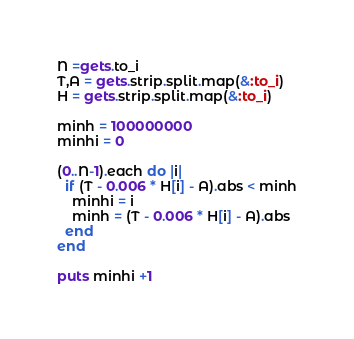Convert code to text. <code><loc_0><loc_0><loc_500><loc_500><_Ruby_>N =gets.to_i
T,A = gets.strip.split.map(&:to_i)
H = gets.strip.split.map(&:to_i)

minh = 100000000
minhi = 0

(0..N-1).each do |i|
  if (T - 0.006 * H[i] - A).abs < minh
    minhi = i
    minh = (T - 0.006 * H[i] - A).abs
  end
end

puts minhi +1</code> 